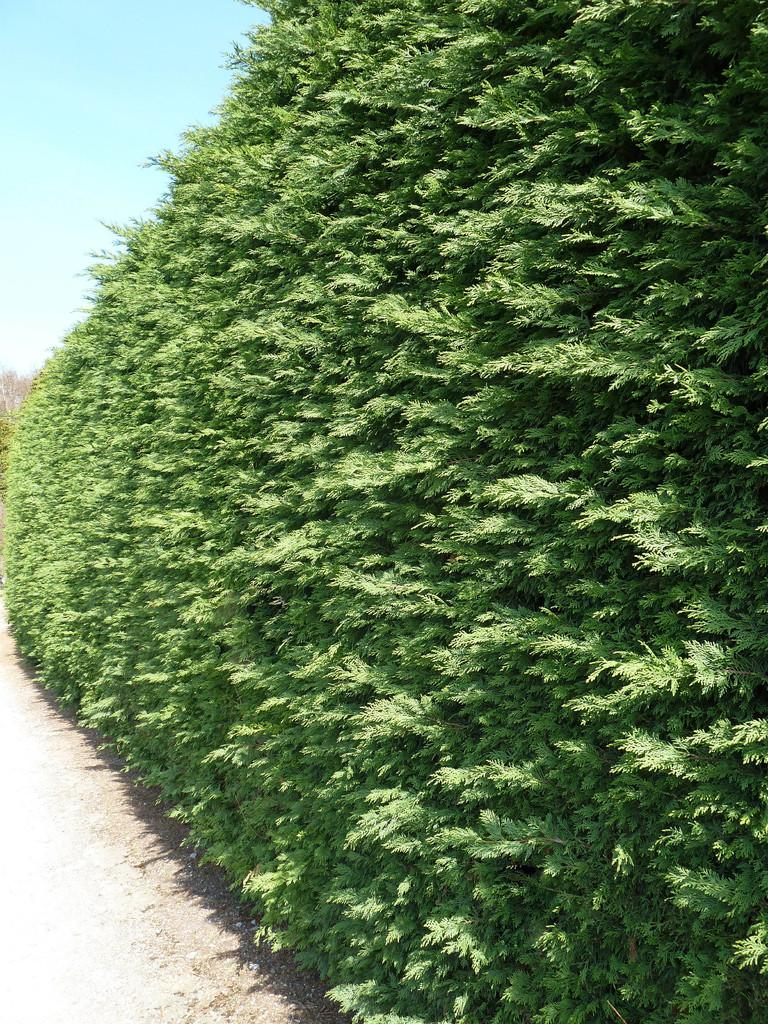What type of vegetation can be seen in the image? There are trees in the image. What color are the trees in the image? The trees are green in color. What color is the sky in the image? The sky is blue in color. What type of cable can be seen hanging from the trees in the image? There is no cable present in the image; it only features trees and a blue sky. 